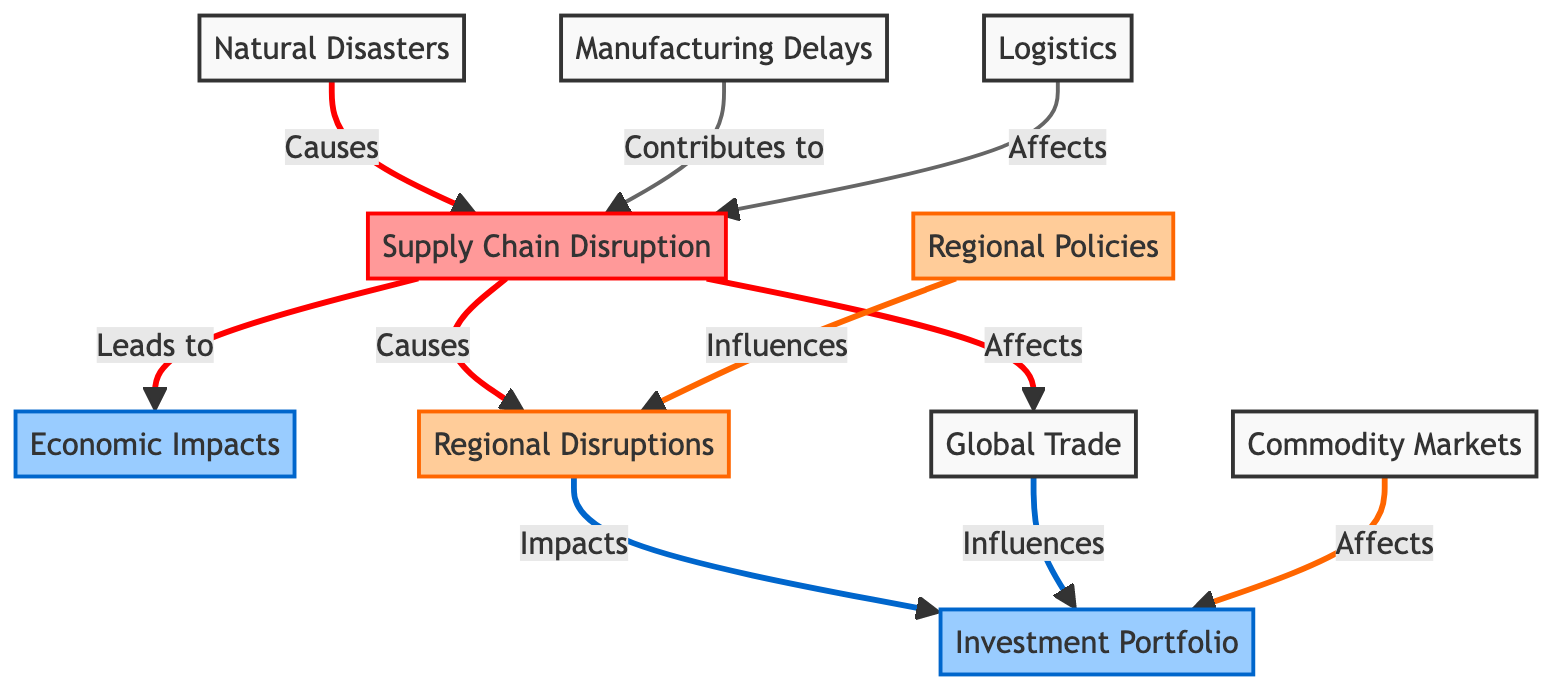What causes supply chain disruption? The diagram indicates that natural disasters are the cause of supply chain disruption, as denoted by the directed arrow labeled "Causes" leading from "Natural Disasters" to "Supply Chain Disruption."
Answer: Natural Disasters How many nodes are in the diagram? Counting the nodes listed, there are a total of 10 distinct nodes represented in the diagram.
Answer: 10 What is impacted by regional disruptions? The diagram shows that regional disruptions have a direct impact on the investment portfolio, as indicated by the arrow labeled "Impacts" pointing from "Regional Disruptions" to "Investment Portfolio."
Answer: Investment Portfolio What influences the investment portfolio? There are multiple nodes that influence the investment portfolio, specifically: global trade and commodity markets. The arrows labeled "Influences" and "Affects" indicate their relationship to the investment portfolio.
Answer: Global Trade, Commodity Markets What contributes to supply chain disruption? The diagram identifies two factors that contribute to supply chain disruption: manufacturing delays and logistics, as shown by the arrows labeled "Contributes to" and "Affects."
Answer: Manufacturing Delays, Logistics What leads to economic impacts? According to the diagram, the supply chain disruption leads to economic impacts, as indicated by the arrow labeled "Leads to" that connects "Supply Chain Disruption" to "Economic Impacts."
Answer: Economic Impacts What influences regional disruptions? The diagram indicates that regional policies influence regional disruptions, as denoted by the arrow labeled "Influences" from "Regional Policies" to "Regional Disruptions."
Answer: Regional Policies How many impacts are listed from supply chain disruption? There are three impacts arising from supply chain disruption: economic impacts, regional disruptions, and global trade. This can be confirmed by counting the outgoing arrows from the "Supply Chain Disruption" node.
Answer: 3 Which node is affected by logistics? The diagram clearly shows that logistics affects supply chain disruption, as evidenced by the arrow labeled "Affects" pointing from "Logistics" to "Supply Chain Disruption."
Answer: Supply Chain Disruption 